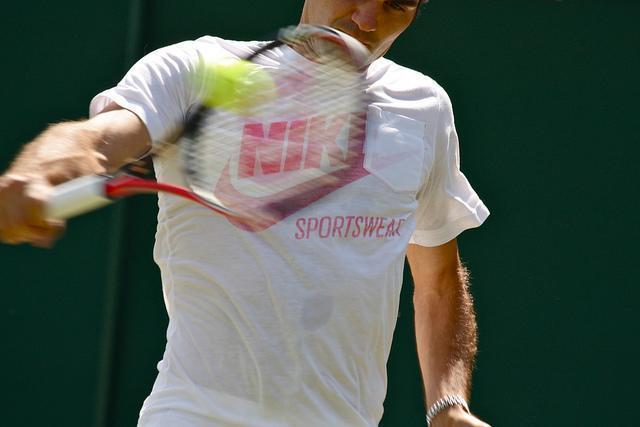Which country houses the headquarter of the brand company manufacturing the man's shirt?
Indicate the correct choice and explain in the format: 'Answer: answer
Rationale: rationale.'
Options: United states, italy, britain, france. Answer: united states.
Rationale: The shirt most likely says "nike sportswear" and their headquarters are in the usa. 